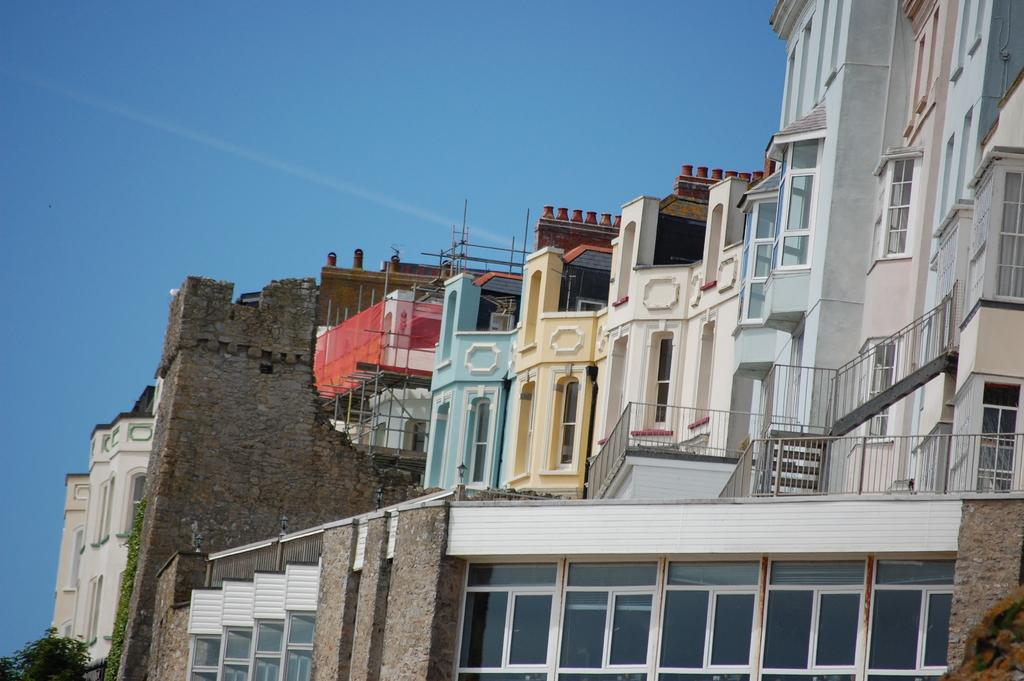What type of structures can be seen in the image? There are buildings in the image. What is separating the buildings from the other objects in the image? There is a fence in the image. What type of plant is present in the image? There is a tree in the image. What else can be seen in the image besides the buildings, fence, and tree? There are other objects in the image. What is visible in the background of the image? The sky is visible in the background of the image. Can you tell me how many owls are sitting on the fence in the image? There are no owls present in the image; it features buildings, a fence, a tree, and other objects. What type of emotion is displayed by the buildings in the image? Buildings do not display emotions; they are inanimate objects. 